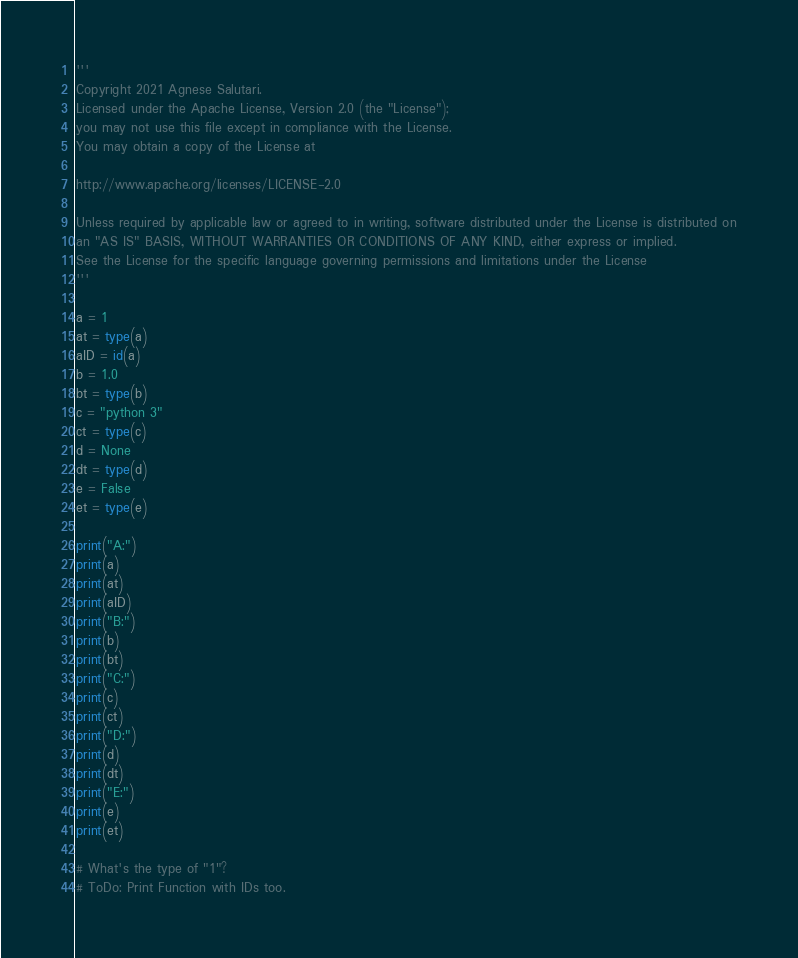<code> <loc_0><loc_0><loc_500><loc_500><_Python_>
'''
Copyright 2021 Agnese Salutari.
Licensed under the Apache License, Version 2.0 (the "License");
you may not use this file except in compliance with the License.
You may obtain a copy of the License at

http://www.apache.org/licenses/LICENSE-2.0

Unless required by applicable law or agreed to in writing, software distributed under the License is distributed on
an "AS IS" BASIS, WITHOUT WARRANTIES OR CONDITIONS OF ANY KIND, either express or implied.
See the License for the specific language governing permissions and limitations under the License
'''

a = 1
at = type(a)
aID = id(a)
b = 1.0
bt = type(b)
c = "python 3"
ct = type(c)
d = None
dt = type(d)
e = False
et = type(e)

print("A:")
print(a)
print(at)
print(aID)
print("B:")
print(b)
print(bt)
print("C:")
print(c)
print(ct)
print("D:")
print(d)
print(dt)
print("E:")
print(e)
print(et)

# What's the type of "1"?
# ToDo: Print Function with IDs too.
</code> 